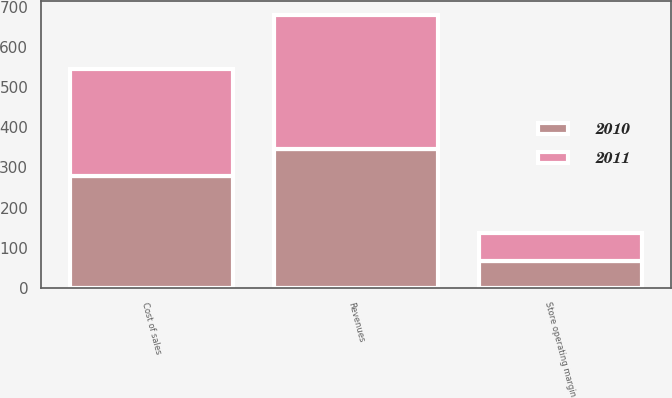Convert chart. <chart><loc_0><loc_0><loc_500><loc_500><stacked_bar_chart><ecel><fcel>Revenues<fcel>Cost of sales<fcel>Store operating margin<nl><fcel>2010<fcel>345.6<fcel>278.3<fcel>67.3<nl><fcel>2011<fcel>336.3<fcel>267.1<fcel>69.3<nl></chart> 